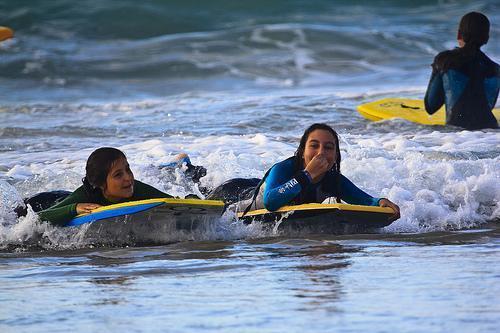How many children are surfing?
Give a very brief answer. 3. 